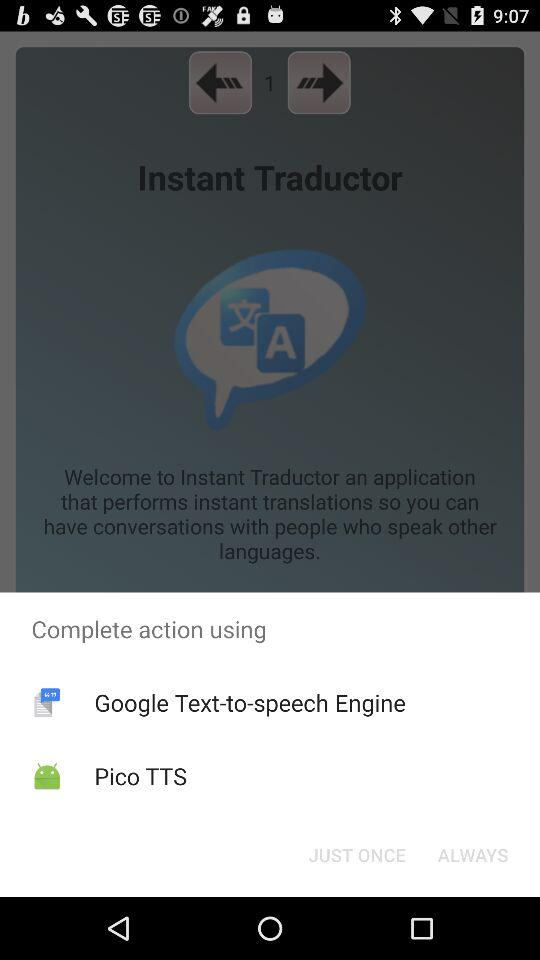What are the different options through which we can complete the action? The different options are "Google Text-to-speech Engine" and "Pico TTS". 